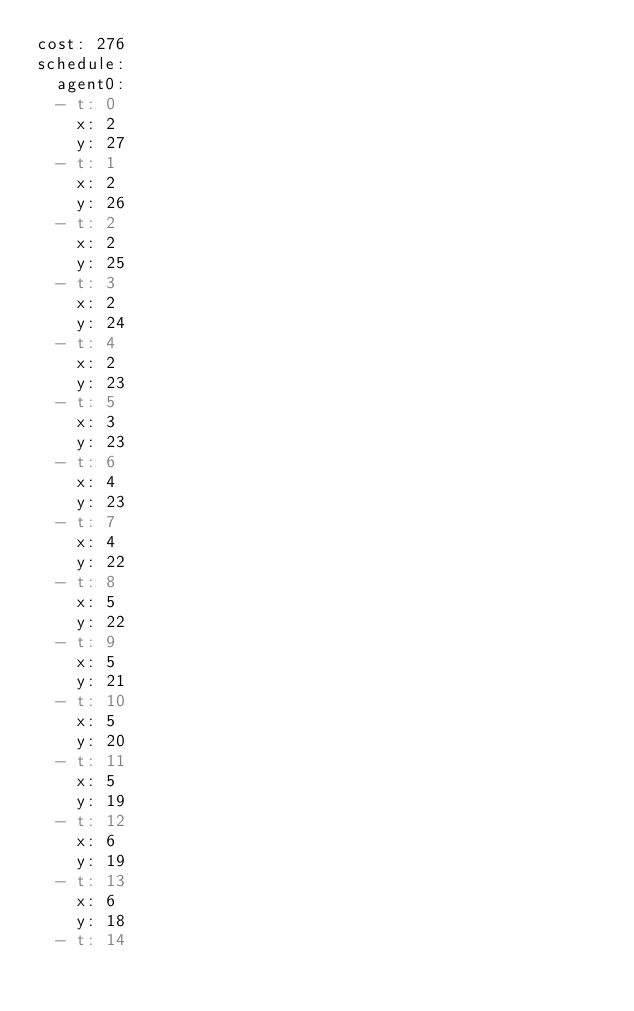<code> <loc_0><loc_0><loc_500><loc_500><_YAML_>cost: 276
schedule:
  agent0:
  - t: 0
    x: 2
    y: 27
  - t: 1
    x: 2
    y: 26
  - t: 2
    x: 2
    y: 25
  - t: 3
    x: 2
    y: 24
  - t: 4
    x: 2
    y: 23
  - t: 5
    x: 3
    y: 23
  - t: 6
    x: 4
    y: 23
  - t: 7
    x: 4
    y: 22
  - t: 8
    x: 5
    y: 22
  - t: 9
    x: 5
    y: 21
  - t: 10
    x: 5
    y: 20
  - t: 11
    x: 5
    y: 19
  - t: 12
    x: 6
    y: 19
  - t: 13
    x: 6
    y: 18
  - t: 14</code> 